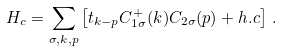<formula> <loc_0><loc_0><loc_500><loc_500>H _ { c } = \sum _ { \sigma , { k } , { p } } \left [ t _ { { k } - { p } } C ^ { + } _ { 1 \sigma } ( { k } ) C _ { 2 \sigma } ( { p } ) + h . c \right ] \, .</formula> 